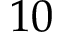<formula> <loc_0><loc_0><loc_500><loc_500>1 0</formula> 